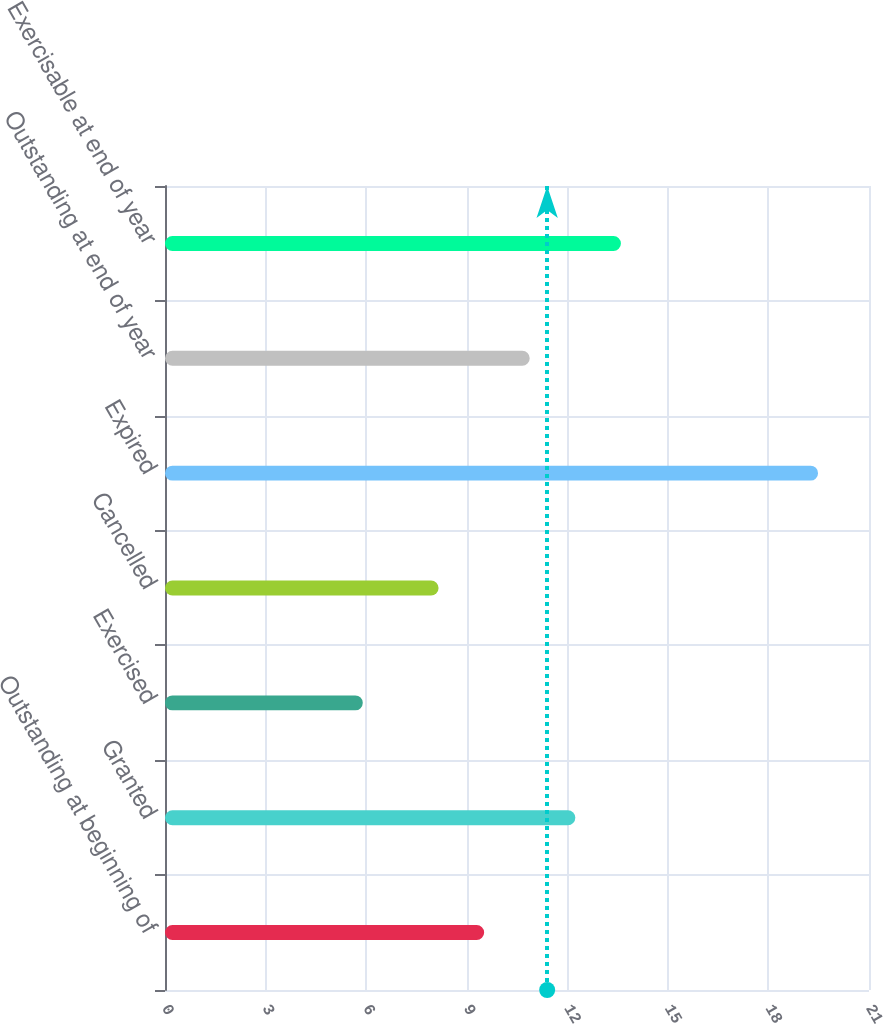Convert chart. <chart><loc_0><loc_0><loc_500><loc_500><bar_chart><fcel>Outstanding at beginning of<fcel>Granted<fcel>Exercised<fcel>Cancelled<fcel>Expired<fcel>Outstanding at end of year<fcel>Exercisable at end of year<nl><fcel>9.52<fcel>12.24<fcel>5.9<fcel>8.16<fcel>19.48<fcel>10.88<fcel>13.6<nl></chart> 